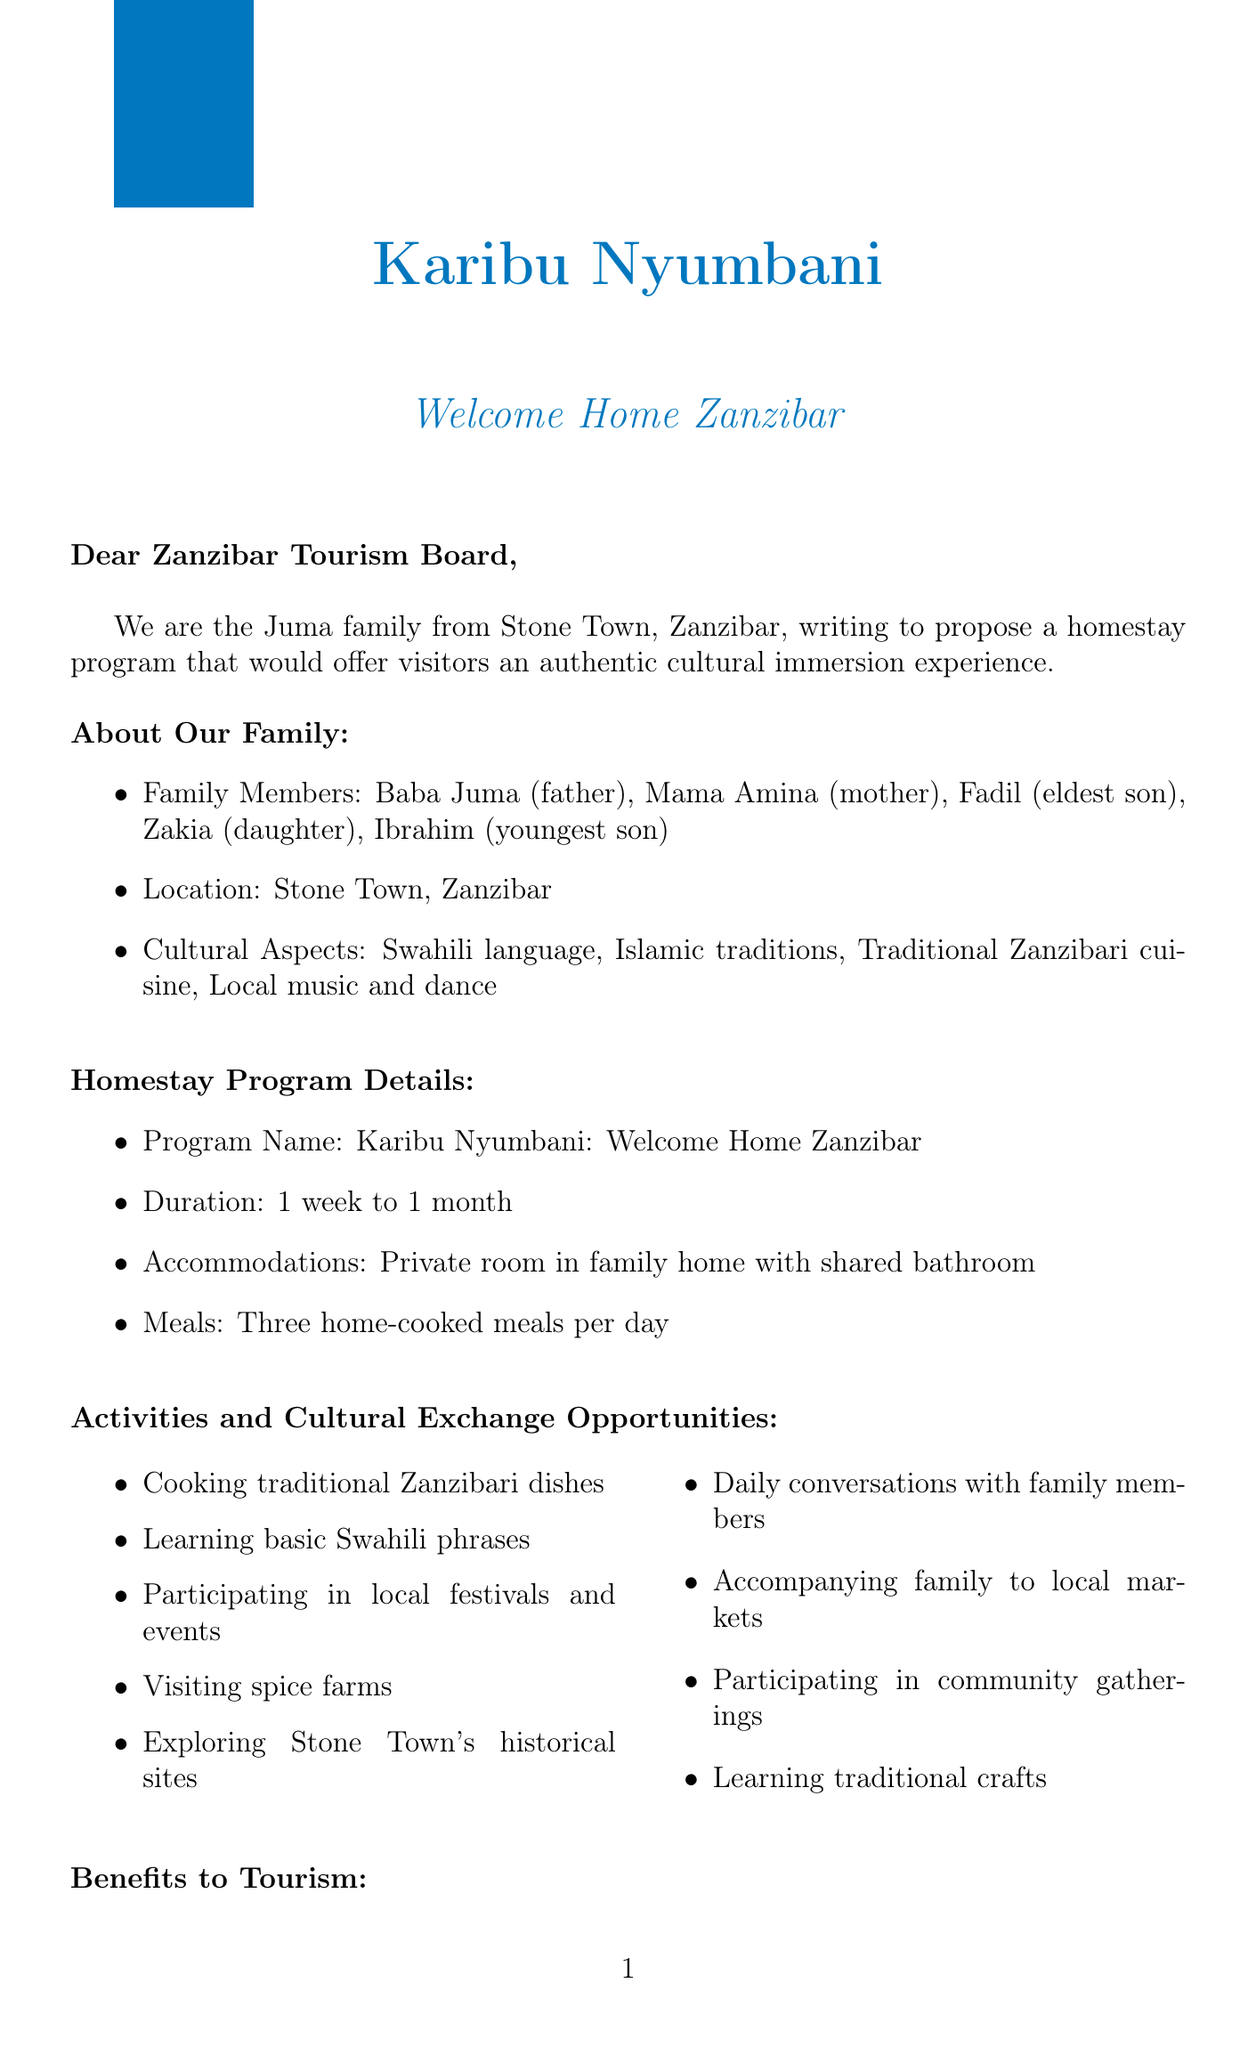What is the name of the family proposing the homestay program? The family's name is mentioned at the beginning of the letter as the Juma family.
Answer: Juma What is the duration of the homestay program? The letter specifically states that the program duration ranges from one week to one month.
Answer: 1 week to 1 month What cultural aspects are highlighted by the Juma family? The document lists several cultural aspects, which include the Swahili language, Islamic traditions, traditional Zanzibari cuisine, and local music and dance.
Answer: Swahili language, Islamic traditions, Traditional Zanzibari cuisine, Local music and dance How many families will start the pilot program? The implementation plan indicates that the pilot program will start with five to ten families in Stone Town.
Answer: 5-10 families What kind of meals will participants receive during the homestay? The document specifies that participants will receive three home-cooked meals per day during their stay.
Answer: Three home-cooked meals per day What support is needed from the Zanzibar Tourism Board? The document lists various support needed, including official endorsement, assistance in developing guidelines, help in promotion, and potential funding.
Answer: Official endorsement What is one benefit to tourists mentioned in the document? The letter outlines that the program will provide an authentic cultural immersion experience for visitors.
Answer: Authentic cultural immersion experience What activities will guests participate in during their stay? Guests are expected to engage in activities such as cooking traditional Zanzibari dishes, learning basic Swahili phrases, and exploring historical sites.
Answer: Cooking traditional Zanzibari dishes, learning basic Swahili phrases, participating in local festivals and events, visiting spice farms, exploring historical sites 